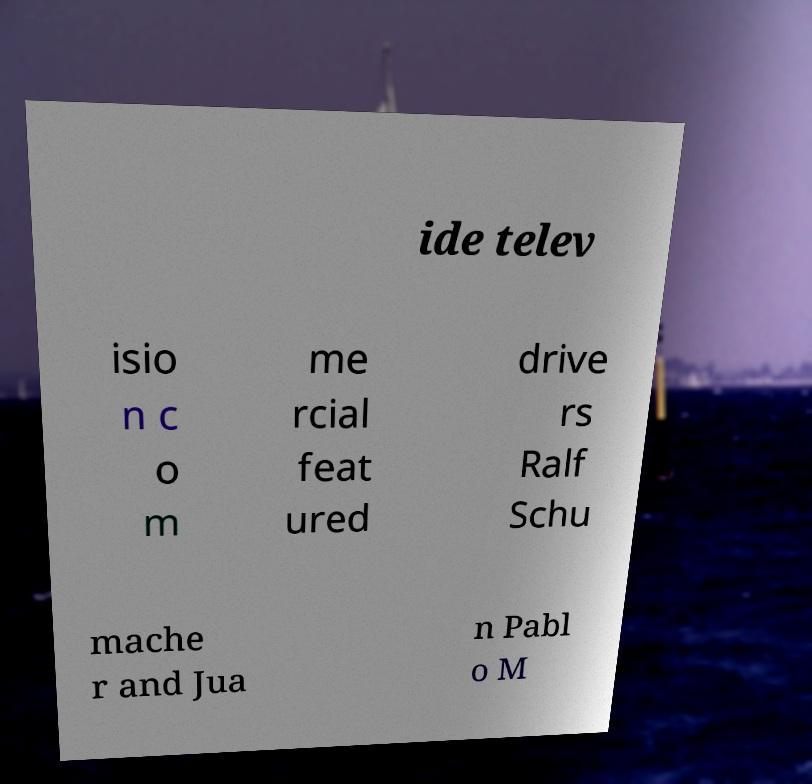Please read and relay the text visible in this image. What does it say? ide telev isio n c o m me rcial feat ured drive rs Ralf Schu mache r and Jua n Pabl o M 